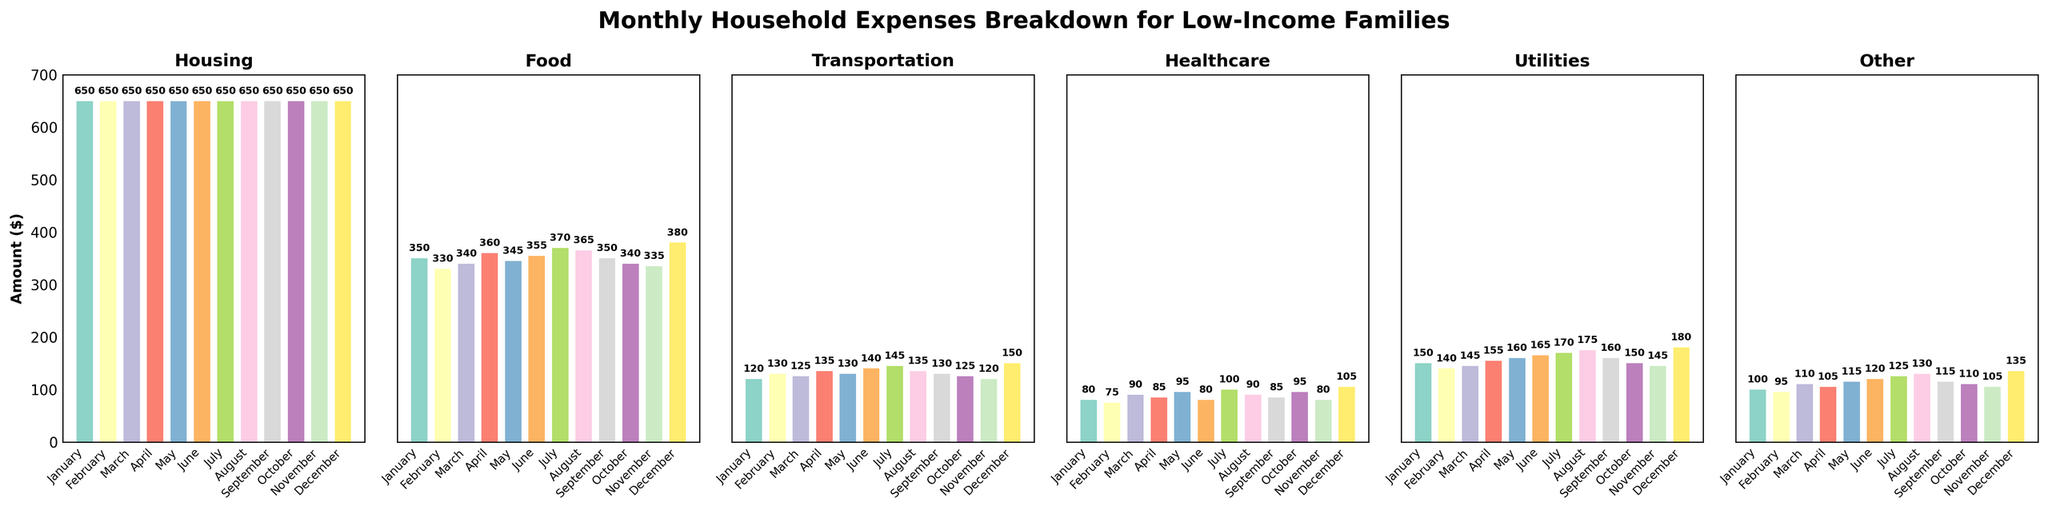How does the expenditure on transportation in January compare to that in July? Look at the heights of the bars for Transportation in January and July in the corresponding subplot. January is 120 and July is 145. Since 145 is greater than 120, July's transportation expense is higher.
Answer: July's transportation expense is higher What is the average monthly expenditure on utilities from January to December? Add the utility expenses for each month and divide by the number of months. (150+140+145+155+160+165+170+175+160+150+145+180)/12 = 1895/12 = 157.92
Answer: 157.92 What is the total expenditure on food in March and May? Add the food expenses for March and May. For March, it is 340 and for May, it is 345. So the total is 340+345 = 685.
Answer: 685 Which category had the highest expenditure in December? Look at the bars for December in each subplot. The highest bar corresponds to the Food category with 380.
Answer: Food Is the expenditure on healthcare in February greater than in April? Compare the heights of the bars for Healthcare in February and April in the corresponding subplot. February is 75 and April is 85. Since 85 is greater than 75, April's healthcare expense is higher.
Answer: No What is the difference in housing expenditure between any two months? The housing expenditure is constant at 650 for all months, so the difference between any two months is 650-650 = 0.
Answer: 0 Which month shows the highest expenditure on 'Other' items, and what is the value? Look at the bars for each month in the 'Other' category subplot. The highest bar is in December with a value of 135.
Answer: December, 135 